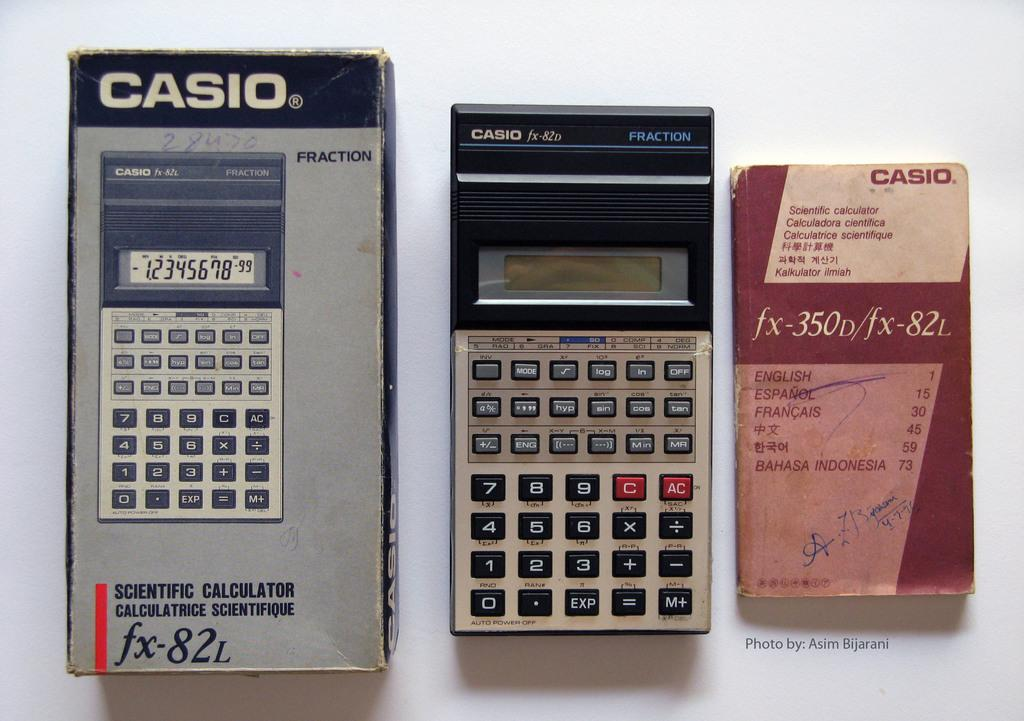<image>
Relay a brief, clear account of the picture shown. A casio brand calculator in the middle of the box and the instruction book. 